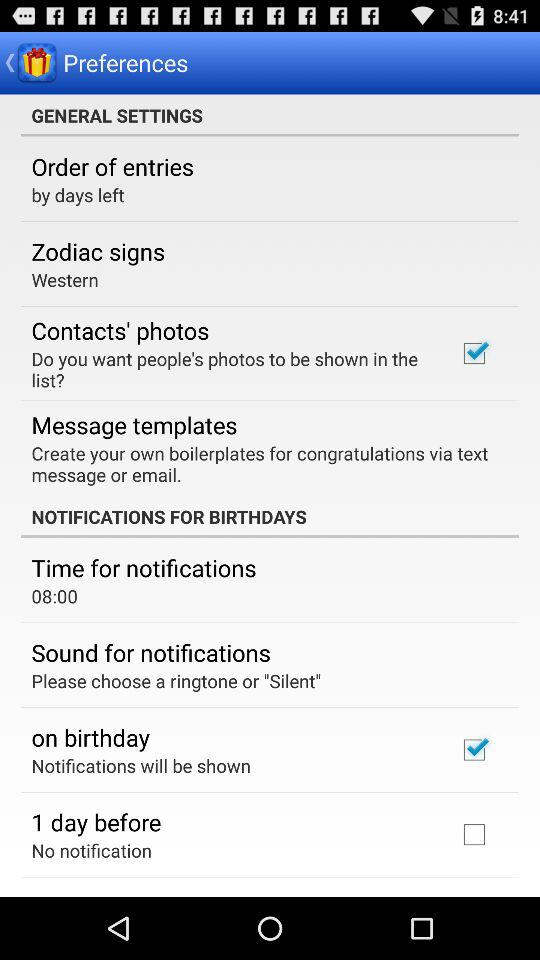What time is set for notifications? The time set for notifications is 8:00. 